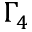<formula> <loc_0><loc_0><loc_500><loc_500>\Gamma _ { 4 }</formula> 